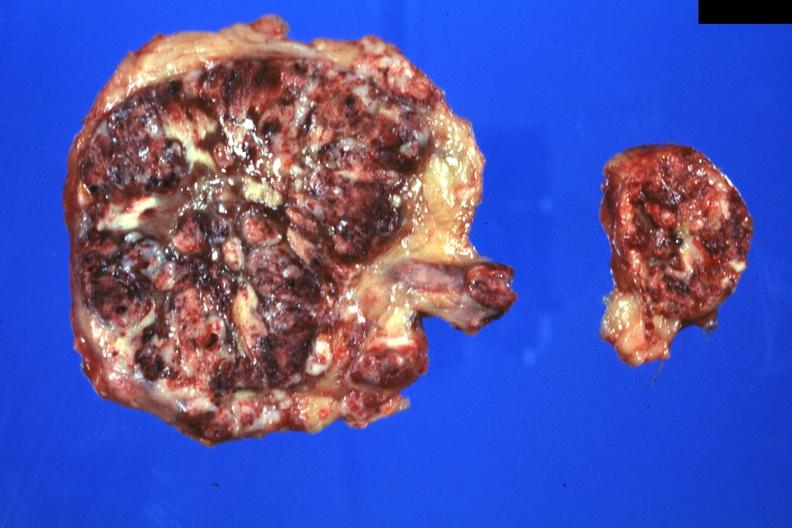what is present?
Answer the question using a single word or phrase. Endocrine 